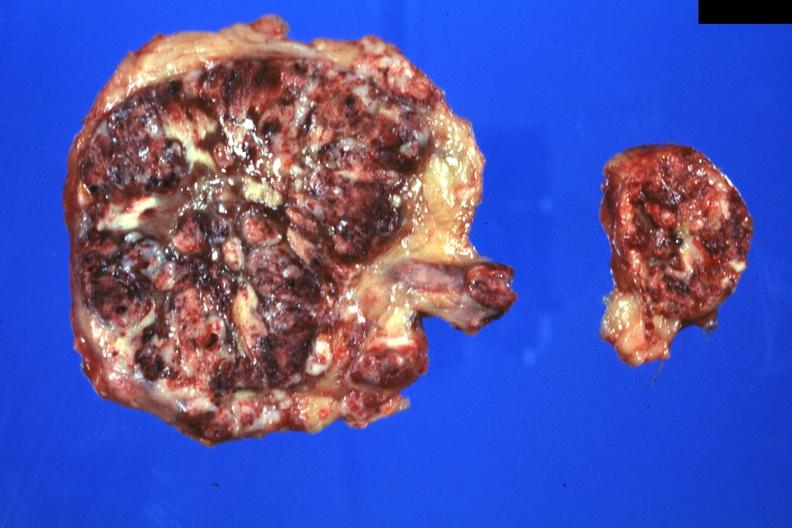what is present?
Answer the question using a single word or phrase. Endocrine 